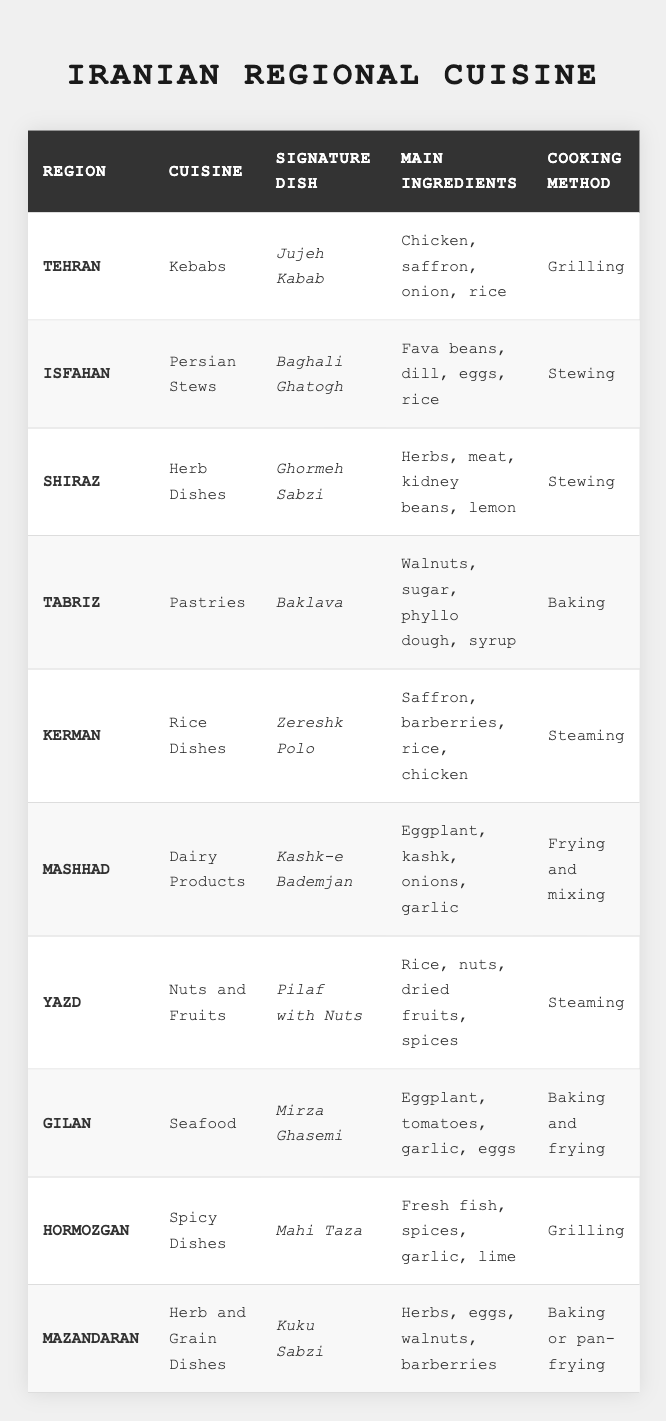What is the signature dish from Tehran? From the first row of the table, we can see that the region "Tehran" has the signature dish listed as "Jujeh Kabab."
Answer: Jujeh Kabab Which region is known for its pastries? By looking at the table, we find that the region "Tabriz" is associated with pastries, specifically the signature dish "Baklava."
Answer: Tabriz How many regions have stewing as a cooking method? Checking the cooking method column, we identify three regions: Isfahan (Baghali Ghatogh), Shiraz (Ghormeh Sabzi), and Kerman (Zereshk Polo), all indicating "Stewing." So there are three regions.
Answer: 3 What are the main ingredients of the signature dish from Kerman? According to the table, Kerman's signature dish "Zereshk Polo" includes main ingredients: "Saffron, barberries, rice, chicken."
Answer: Saffron, barberries, rice, chicken Is "Mahi Taza" a seafood dish? "Mahi Taza" is listed under Hormozgan, which is known for spicy dishes, not seafood. Therefore, the fact is false.
Answer: No What is the difference in cooking methods between the dishes from Kerman and Gilan? The table indicates that Kerman uses steaming for "Zereshk Polo," while Gilan uses baking and frying for "Mirza Ghasemi." The difference is in the methods: one is steaming and the other is a combination of baking and frying.
Answer: Steaming vs. Baking and frying Which region's signature dish includes fresh fish? Locating the region that mentions fresh fish, we find "Mahi Taza" listed under the region "Hormozgan," confirming it includes fresh fish.
Answer: Hormozgan How many main ingredients does the signature dish "Ghormeh Sabzi" have? The table shows that "Ghormeh Sabzi" has four main ingredients listed: herbs, meat, kidney beans, and lemon. Thus, the total is four.
Answer: 4 In which regions do they cook using grilling? From the table, both Tehran (Jujeh Kabab) and Hormozgan (Mahi Taza) use grilling as a cooking method. Therefore, the two regions known for grilling are Tehran and Hormozgan.
Answer: Tehran and Hormozgan Which dish contains eggplant as one of its main ingredients? The table lists "Kashk-e Bademjan" from Mashhad and "Mirza Ghasemi" from Gilan as dishes that contain eggplant in their main ingredients.
Answer: Kashk-e Bademjan and Mirza Ghasemi 